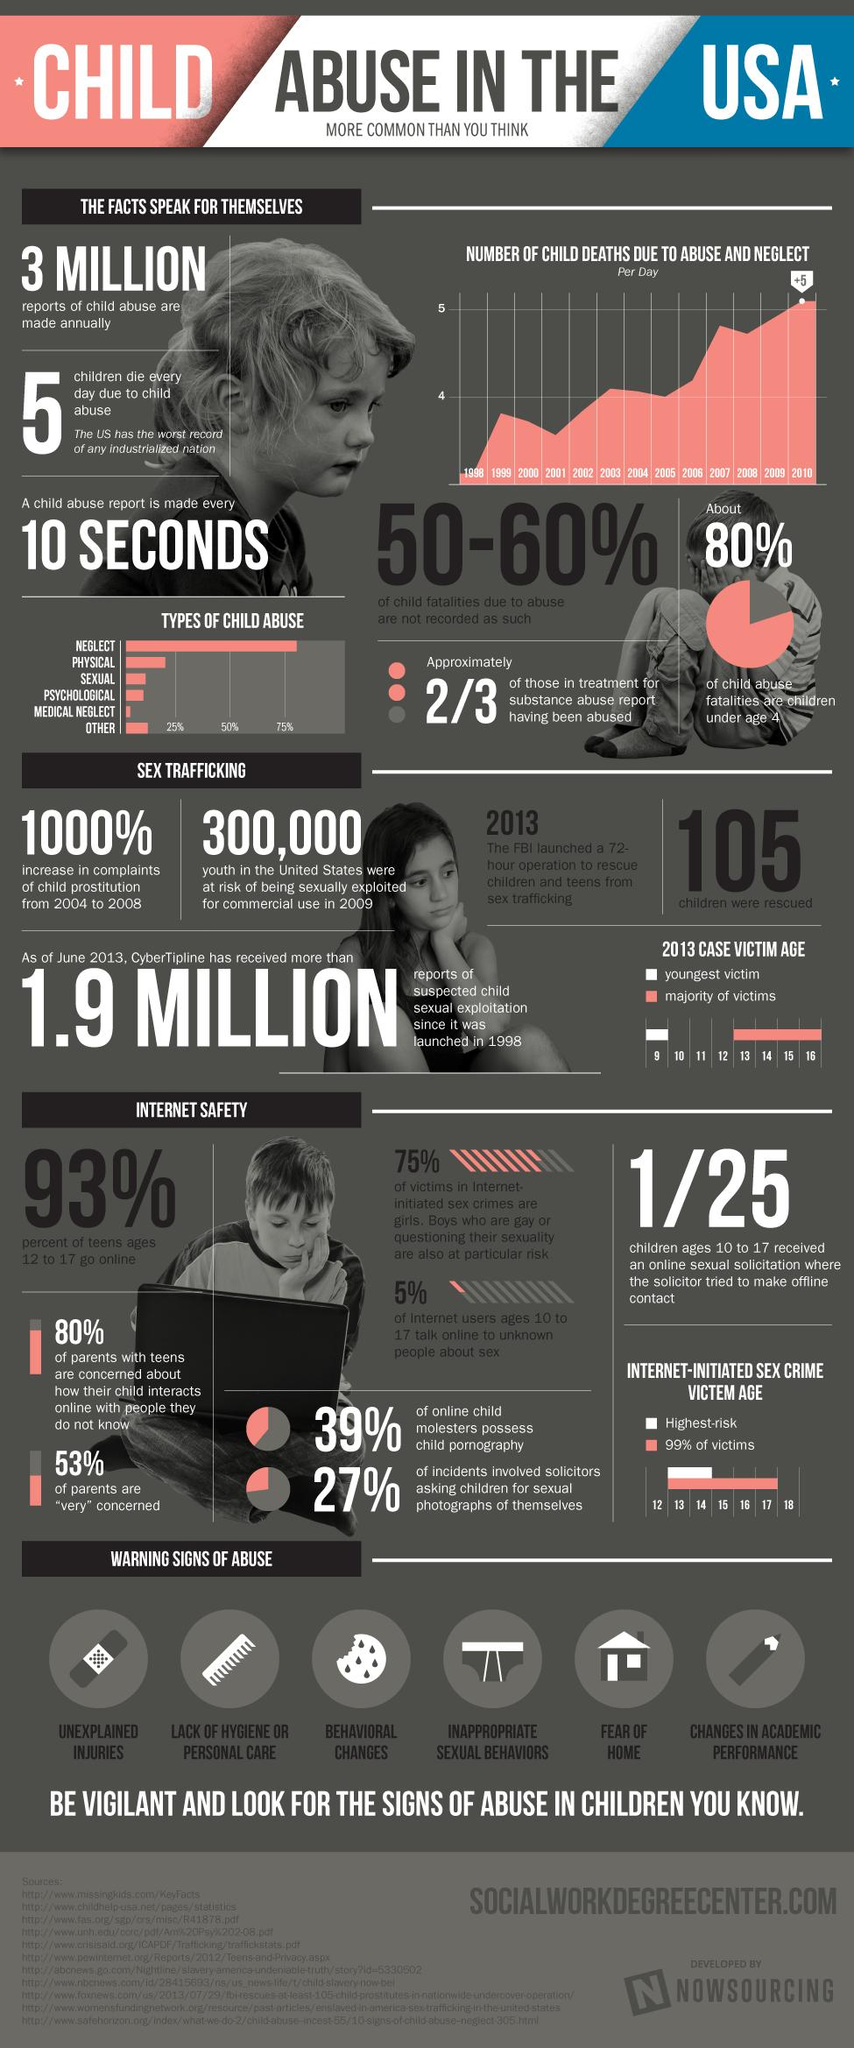Point out several critical features in this image. According to recent data, there has been a significant increase in the number of children engaging in prostitution in the USA, with a percentage increase of 1000% from 2004 to 2008. A significant proportion of teenagers in the United States between the ages of 12 and 17 do not go online, with 7% falling into this category. In 2010, an average of more than 5 children died every day in the United States as a result of abuse and neglect. The FBI launched a 72-hour operation that resulted in the rescue of 105 children from sex trafficking. In 2009, an estimated 300,000 youth in the United States were at risk of being sexually exploited for commercial use. 